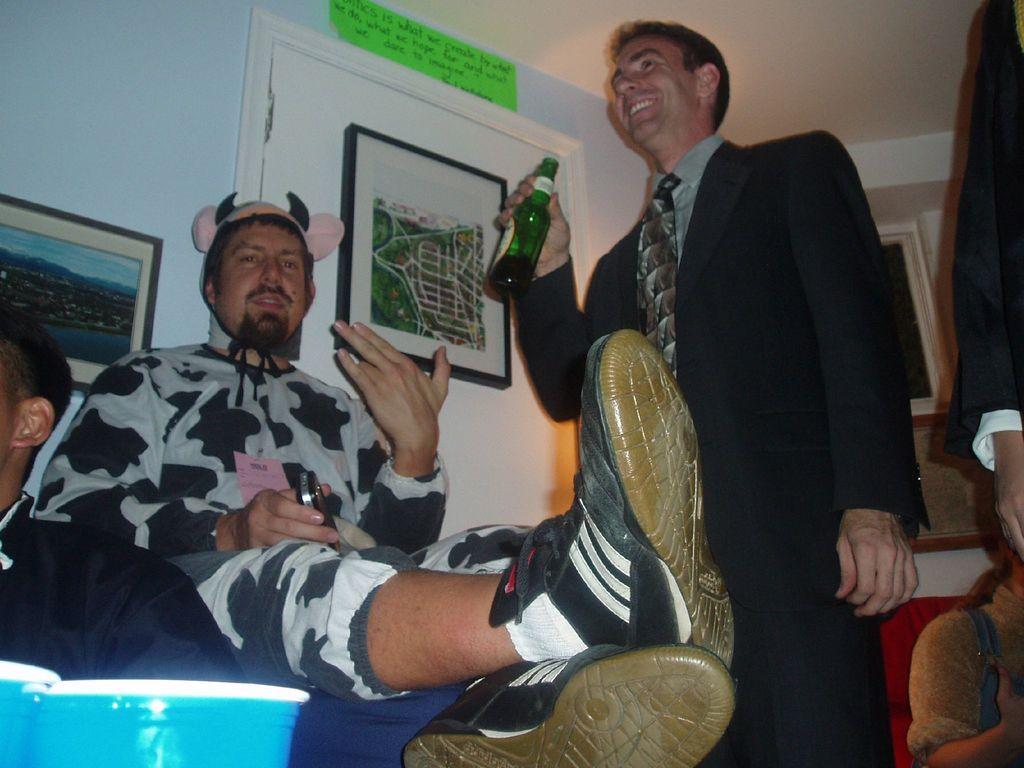Could you give a brief overview of what you see in this image? In this image I can see a man sitting,holding a mobile phone on his hand wearing a cap on his head. I can see another person wearing suit trouser and tie. he is holding a beer bottle on his hand and smiling. At background I can see a photo frame attached to the wall. At the right corner of the image I can see a person sitting and the other person is standing. At the left corner of the image I can see the other person sitting. This is some kind of blue colored object. This is a couch. I can see another photo frame attached to the wall. 